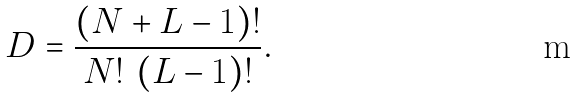<formula> <loc_0><loc_0><loc_500><loc_500>D = \frac { ( N + L - 1 ) ! } { N ! \ ( L - 1 ) ! } .</formula> 